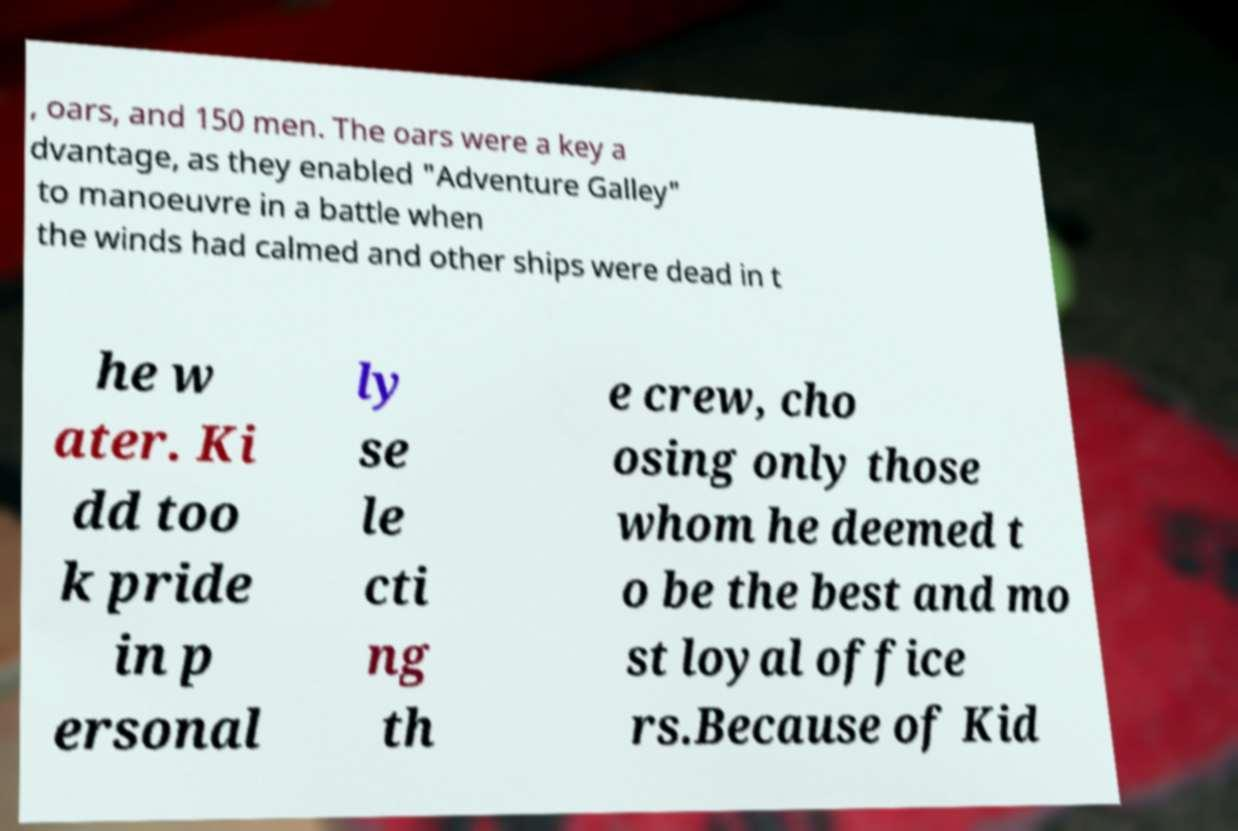I need the written content from this picture converted into text. Can you do that? , oars, and 150 men. The oars were a key a dvantage, as they enabled "Adventure Galley" to manoeuvre in a battle when the winds had calmed and other ships were dead in t he w ater. Ki dd too k pride in p ersonal ly se le cti ng th e crew, cho osing only those whom he deemed t o be the best and mo st loyal office rs.Because of Kid 